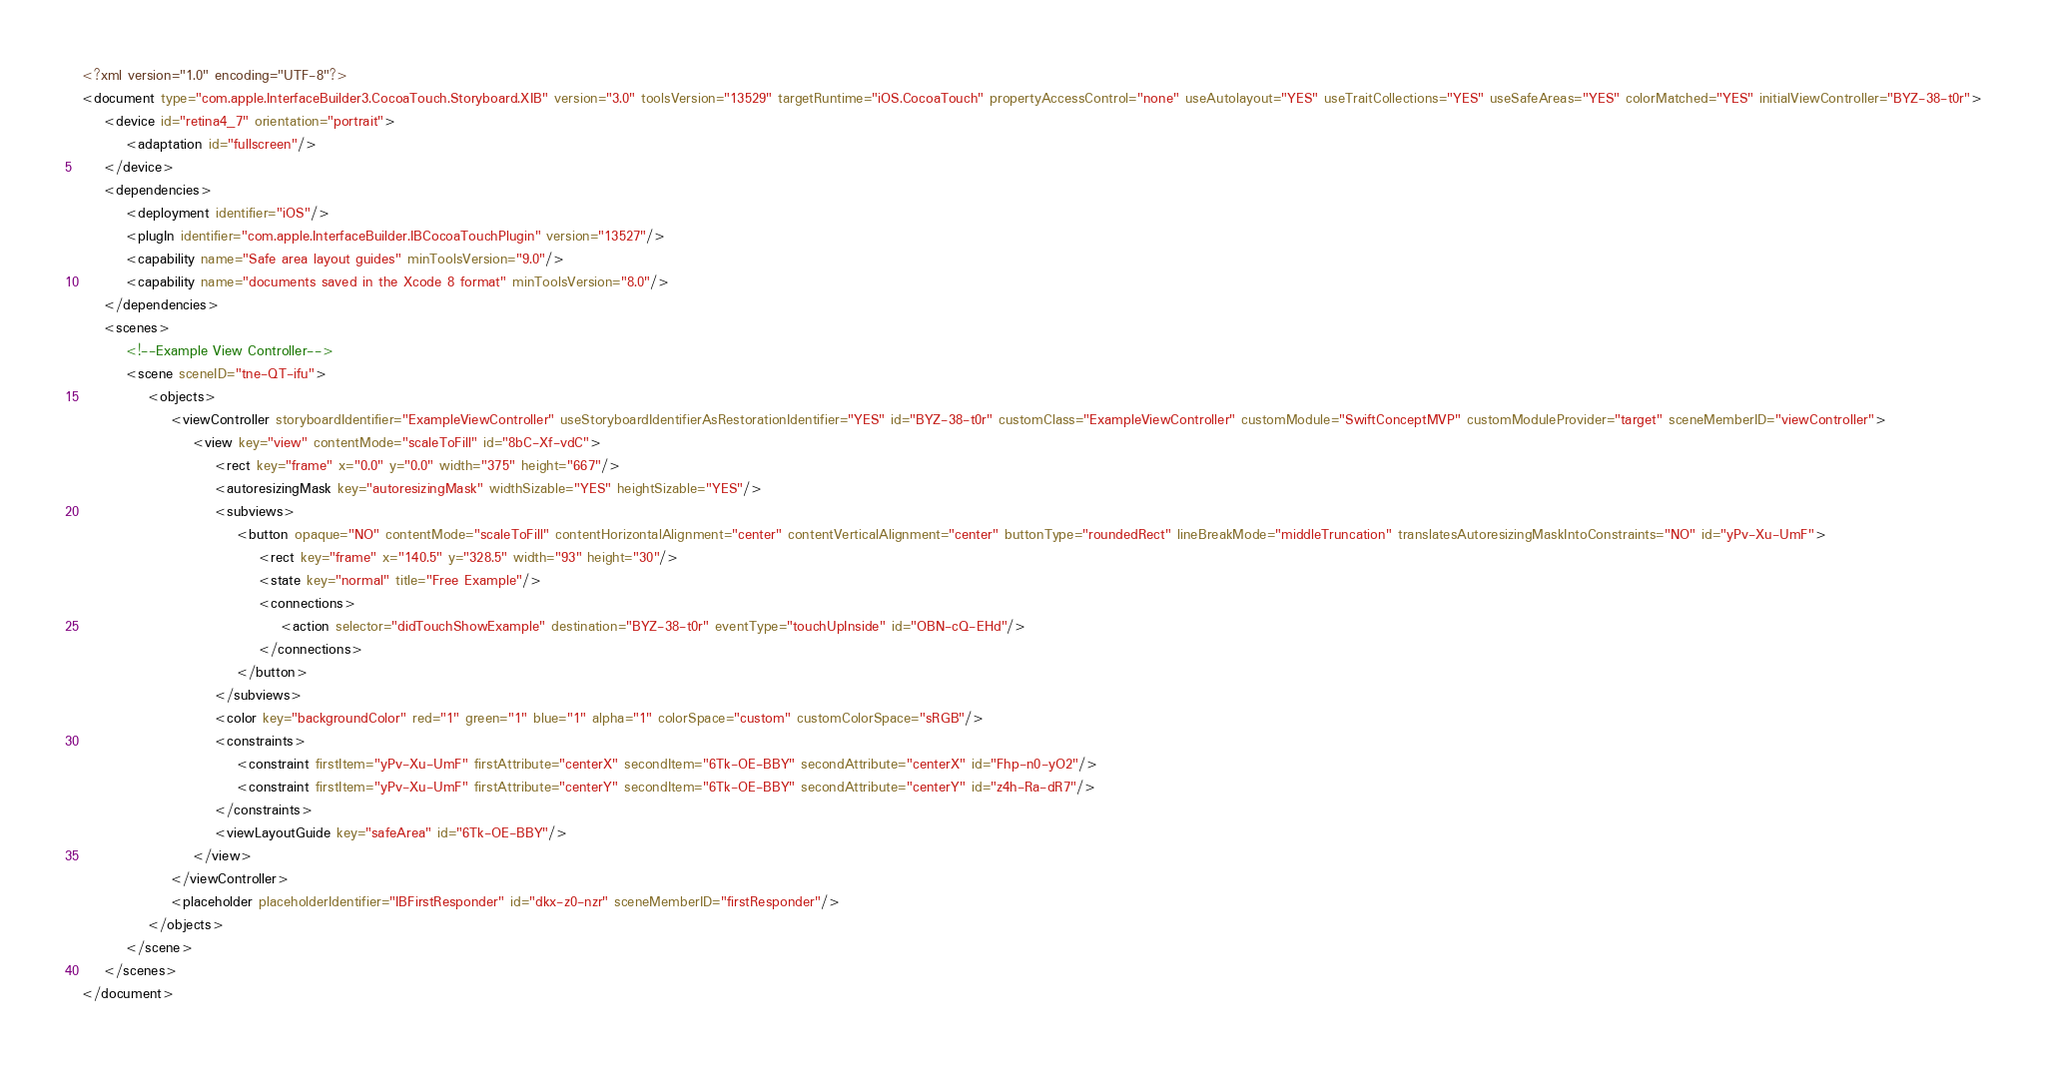<code> <loc_0><loc_0><loc_500><loc_500><_XML_><?xml version="1.0" encoding="UTF-8"?>
<document type="com.apple.InterfaceBuilder3.CocoaTouch.Storyboard.XIB" version="3.0" toolsVersion="13529" targetRuntime="iOS.CocoaTouch" propertyAccessControl="none" useAutolayout="YES" useTraitCollections="YES" useSafeAreas="YES" colorMatched="YES" initialViewController="BYZ-38-t0r">
    <device id="retina4_7" orientation="portrait">
        <adaptation id="fullscreen"/>
    </device>
    <dependencies>
        <deployment identifier="iOS"/>
        <plugIn identifier="com.apple.InterfaceBuilder.IBCocoaTouchPlugin" version="13527"/>
        <capability name="Safe area layout guides" minToolsVersion="9.0"/>
        <capability name="documents saved in the Xcode 8 format" minToolsVersion="8.0"/>
    </dependencies>
    <scenes>
        <!--Example View Controller-->
        <scene sceneID="tne-QT-ifu">
            <objects>
                <viewController storyboardIdentifier="ExampleViewController" useStoryboardIdentifierAsRestorationIdentifier="YES" id="BYZ-38-t0r" customClass="ExampleViewController" customModule="SwiftConceptMVP" customModuleProvider="target" sceneMemberID="viewController">
                    <view key="view" contentMode="scaleToFill" id="8bC-Xf-vdC">
                        <rect key="frame" x="0.0" y="0.0" width="375" height="667"/>
                        <autoresizingMask key="autoresizingMask" widthSizable="YES" heightSizable="YES"/>
                        <subviews>
                            <button opaque="NO" contentMode="scaleToFill" contentHorizontalAlignment="center" contentVerticalAlignment="center" buttonType="roundedRect" lineBreakMode="middleTruncation" translatesAutoresizingMaskIntoConstraints="NO" id="yPv-Xu-UmF">
                                <rect key="frame" x="140.5" y="328.5" width="93" height="30"/>
                                <state key="normal" title="Free Example"/>
                                <connections>
                                    <action selector="didTouchShowExample" destination="BYZ-38-t0r" eventType="touchUpInside" id="OBN-cQ-EHd"/>
                                </connections>
                            </button>
                        </subviews>
                        <color key="backgroundColor" red="1" green="1" blue="1" alpha="1" colorSpace="custom" customColorSpace="sRGB"/>
                        <constraints>
                            <constraint firstItem="yPv-Xu-UmF" firstAttribute="centerX" secondItem="6Tk-OE-BBY" secondAttribute="centerX" id="Fhp-n0-yO2"/>
                            <constraint firstItem="yPv-Xu-UmF" firstAttribute="centerY" secondItem="6Tk-OE-BBY" secondAttribute="centerY" id="z4h-Ra-dR7"/>
                        </constraints>
                        <viewLayoutGuide key="safeArea" id="6Tk-OE-BBY"/>
                    </view>
                </viewController>
                <placeholder placeholderIdentifier="IBFirstResponder" id="dkx-z0-nzr" sceneMemberID="firstResponder"/>
            </objects>
        </scene>
    </scenes>
</document>
</code> 